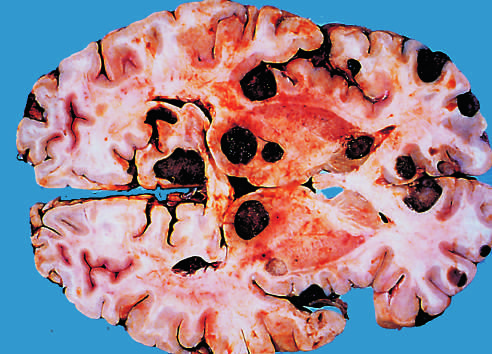s the dark color of the tumor nodules in this specimen due to the presence of melanin?
Answer the question using a single word or phrase. Yes 